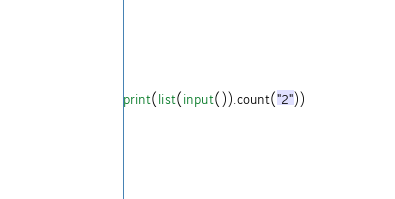<code> <loc_0><loc_0><loc_500><loc_500><_Python_>print(list(input()).count("2"))</code> 